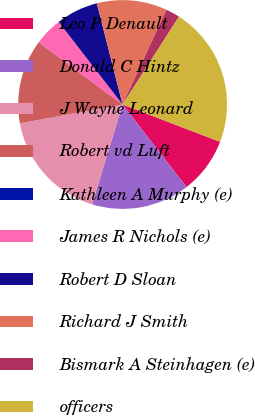<chart> <loc_0><loc_0><loc_500><loc_500><pie_chart><fcel>Leo P Denault<fcel>Donald C Hintz<fcel>J Wayne Leonard<fcel>Robert vd Luft<fcel>Kathleen A Murphy (e)<fcel>James R Nichols (e)<fcel>Robert D Sloan<fcel>Richard J Smith<fcel>Bismark A Steinhagen (e)<fcel>officers<nl><fcel>8.7%<fcel>15.21%<fcel>17.39%<fcel>13.04%<fcel>0.01%<fcel>4.35%<fcel>6.52%<fcel>10.87%<fcel>2.18%<fcel>21.73%<nl></chart> 